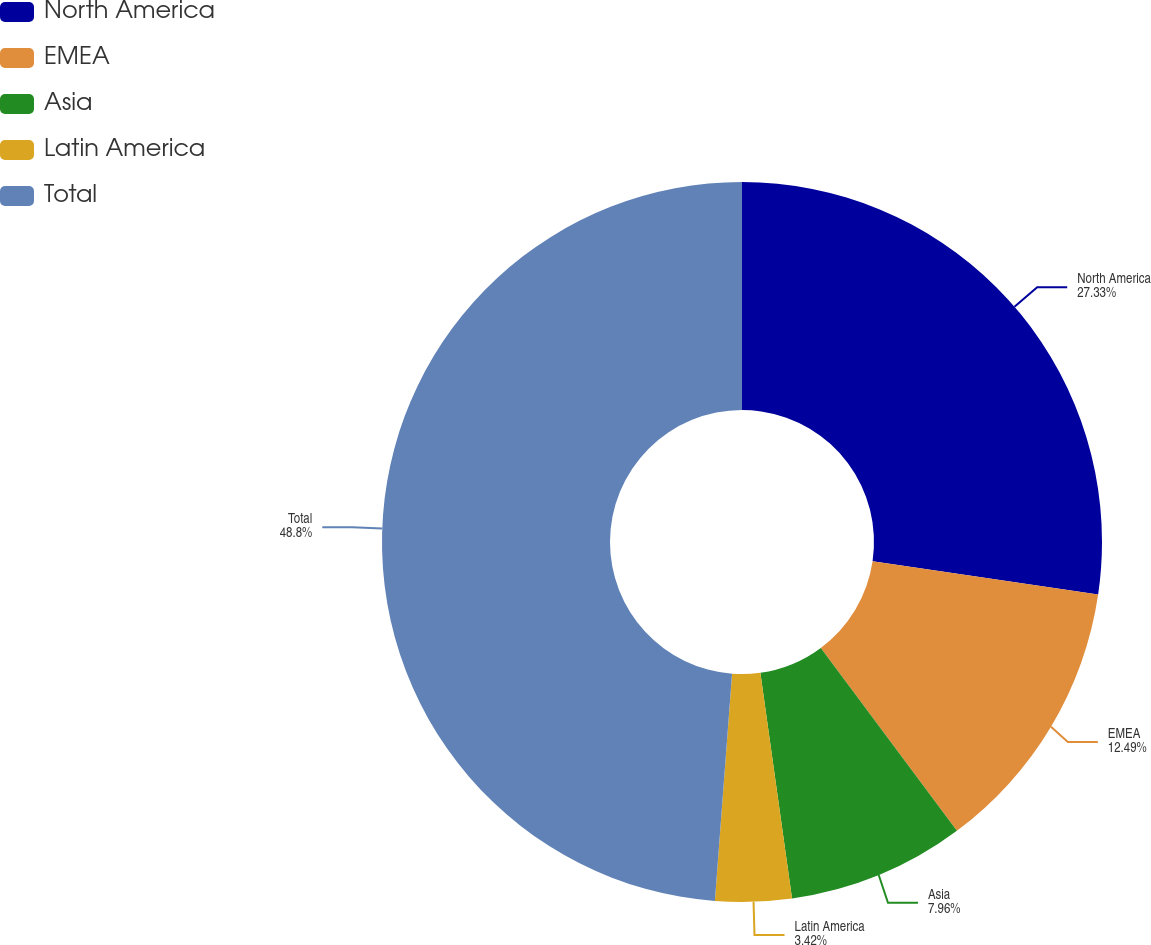Convert chart. <chart><loc_0><loc_0><loc_500><loc_500><pie_chart><fcel>North America<fcel>EMEA<fcel>Asia<fcel>Latin America<fcel>Total<nl><fcel>27.33%<fcel>12.49%<fcel>7.96%<fcel>3.42%<fcel>48.8%<nl></chart> 